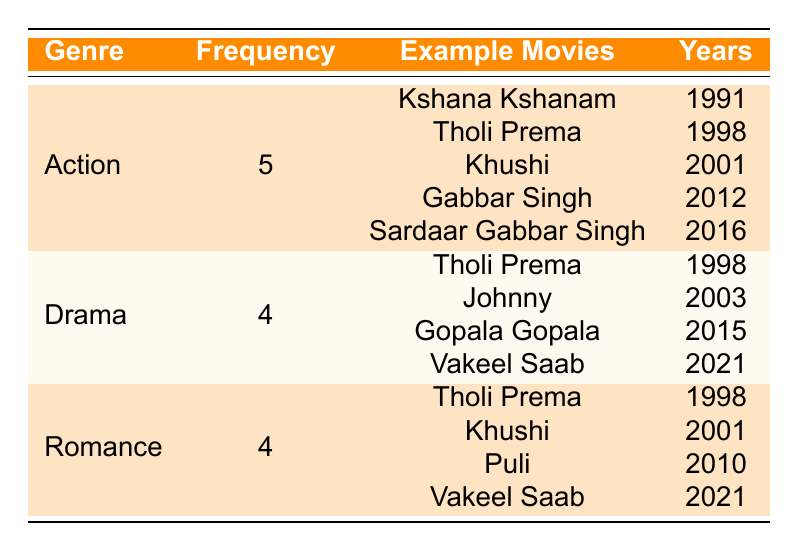What is the genre with the highest frequency of Pawan Kalyan's roles? By looking at the frequency column, we can see that Action has the highest value of 5, while Drama and Romance both have a frequency of 4. Therefore, Action is the genre with the highest frequency.
Answer: Action How many movies has Pawan Kalyan acted in the Drama genre? The table shows that the frequency for the Drama genre is 4, meaning Pawan Kalyan has acted in 4 movies categorized as Drama.
Answer: 4 Are there any genres where Pawan Kalyan has acted in more than 4 movies? By examining the frequency data, Action has 5 movies and both Drama and Romance have 4 movies. Since only Action exceeds 4, the answer is yes.
Answer: Yes What is the total number of movies Pawan Kalyan has acted in across all listed genres? To find the total, we sum the frequencies of all genres: 5 (Action) + 4 (Drama) + 4 (Romance) = 13. Therefore, the total number of movies is 13.
Answer: 13 Which genres have the same frequency, and what is that frequency? Checking the table, both Drama and Romance have a frequency of 4, indicating they are tied in terms of the number of movies.
Answer: Drama and Romance, Frequency: 4 How many more Action movies are there compared to Drama movies? From the table, Action has a frequency of 5 and Drama has a frequency of 4. The difference is 5 - 4 = 1, which means there is 1 more Action movie than there are Drama movies.
Answer: 1 What are the titles of the movies in the Romance genre? Referring to the table under the Romance genre, the titles are Tholi Prema, Khushi, Puli, and Vakeel Saab.
Answer: Tholi Prema, Khushi, Puli, Vakeel Saab Did Pawan Kalyan act in any movies that belong to both the Drama and Romance genres? Looking at the titles, Tholi Prema and Vakeel Saab appear in both genres. Therefore, Pawan Kalyan has acted in 2 movies that are categorized under both genres.
Answer: Yes, 2 movies (Tholi Prema, Vakeel Saab) 